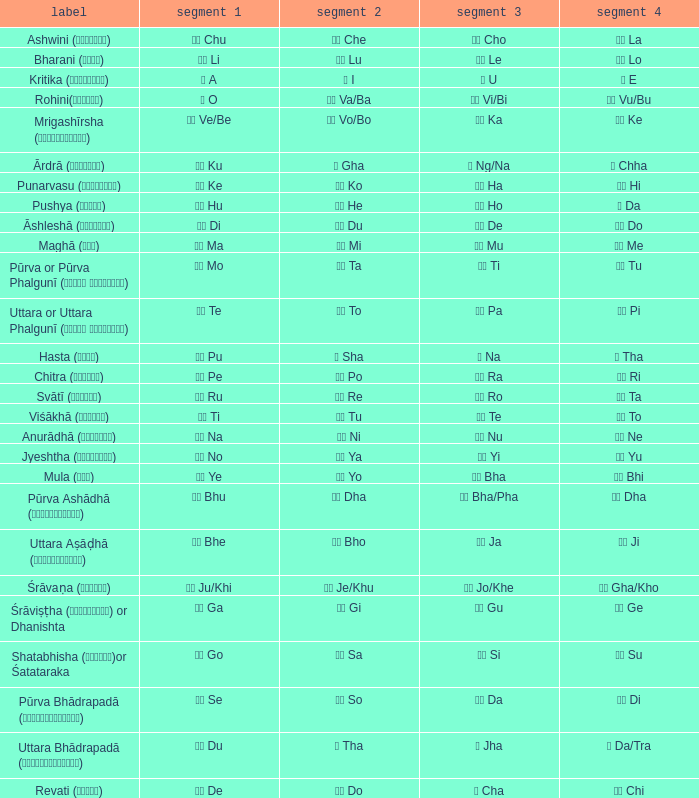What kind of Pada 4 has a Pada 1 of खी ju/khi? खो Gha/Kho. 